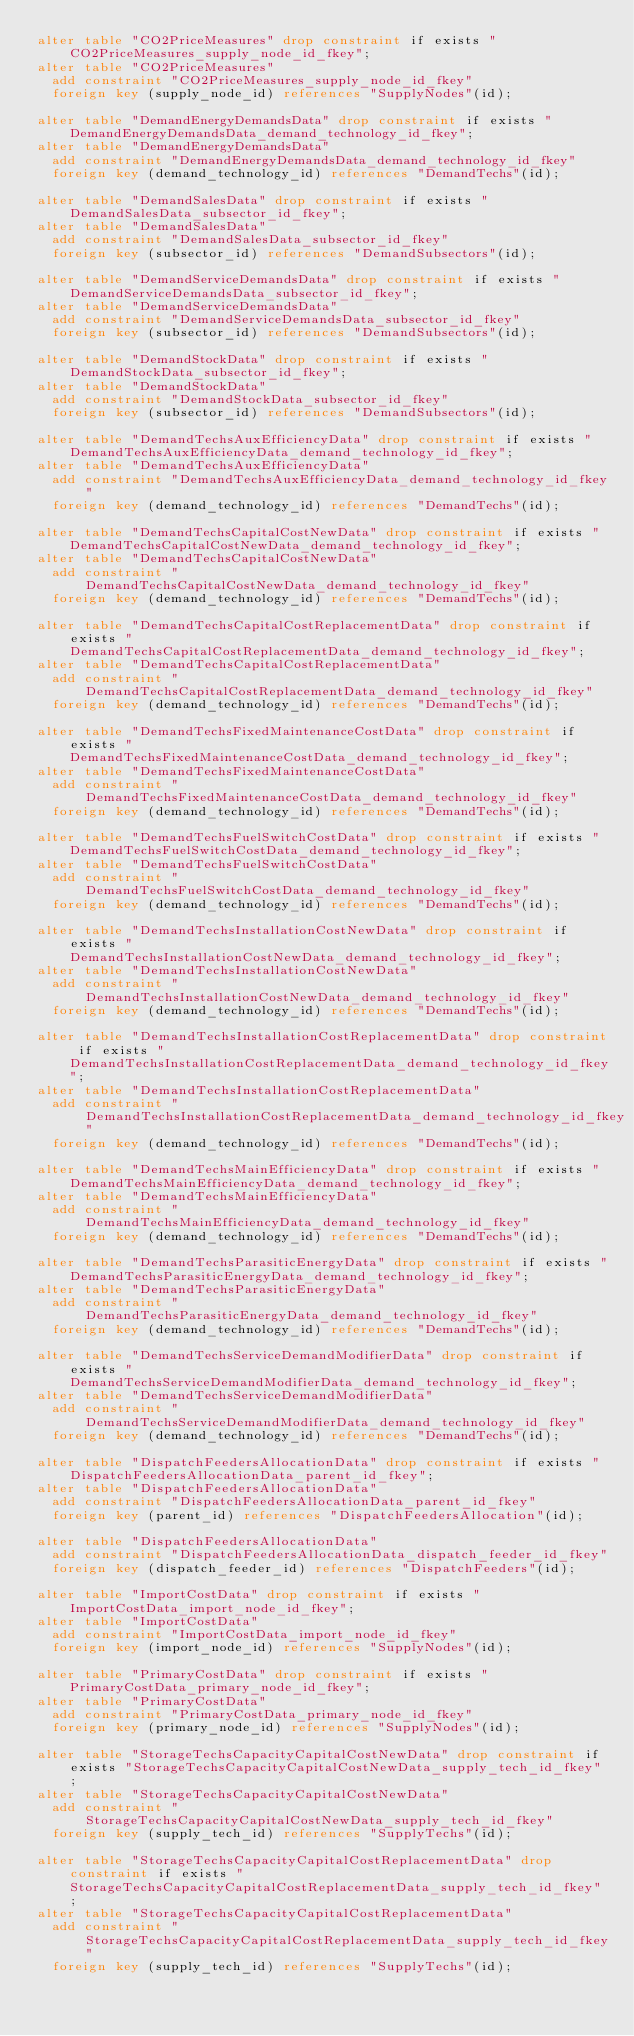Convert code to text. <code><loc_0><loc_0><loc_500><loc_500><_SQL_>alter table "CO2PriceMeasures" drop constraint if exists "CO2PriceMeasures_supply_node_id_fkey";
alter table "CO2PriceMeasures"
  add constraint "CO2PriceMeasures_supply_node_id_fkey"
  foreign key (supply_node_id) references "SupplyNodes"(id);

alter table "DemandEnergyDemandsData" drop constraint if exists "DemandEnergyDemandsData_demand_technology_id_fkey";
alter table "DemandEnergyDemandsData"
  add constraint "DemandEnergyDemandsData_demand_technology_id_fkey"
  foreign key (demand_technology_id) references "DemandTechs"(id);

alter table "DemandSalesData" drop constraint if exists "DemandSalesData_subsector_id_fkey";
alter table "DemandSalesData"
  add constraint "DemandSalesData_subsector_id_fkey"
  foreign key (subsector_id) references "DemandSubsectors"(id);

alter table "DemandServiceDemandsData" drop constraint if exists "DemandServiceDemandsData_subsector_id_fkey";
alter table "DemandServiceDemandsData"
  add constraint "DemandServiceDemandsData_subsector_id_fkey"
  foreign key (subsector_id) references "DemandSubsectors"(id);

alter table "DemandStockData" drop constraint if exists "DemandStockData_subsector_id_fkey";
alter table "DemandStockData"
  add constraint "DemandStockData_subsector_id_fkey"
  foreign key (subsector_id) references "DemandSubsectors"(id);

alter table "DemandTechsAuxEfficiencyData" drop constraint if exists "DemandTechsAuxEfficiencyData_demand_technology_id_fkey";
alter table "DemandTechsAuxEfficiencyData"
  add constraint "DemandTechsAuxEfficiencyData_demand_technology_id_fkey"
  foreign key (demand_technology_id) references "DemandTechs"(id);

alter table "DemandTechsCapitalCostNewData" drop constraint if exists "DemandTechsCapitalCostNewData_demand_technology_id_fkey";
alter table "DemandTechsCapitalCostNewData"
  add constraint "DemandTechsCapitalCostNewData_demand_technology_id_fkey"
  foreign key (demand_technology_id) references "DemandTechs"(id);

alter table "DemandTechsCapitalCostReplacementData" drop constraint if exists "DemandTechsCapitalCostReplacementData_demand_technology_id_fkey";
alter table "DemandTechsCapitalCostReplacementData"
  add constraint "DemandTechsCapitalCostReplacementData_demand_technology_id_fkey"
  foreign key (demand_technology_id) references "DemandTechs"(id);

alter table "DemandTechsFixedMaintenanceCostData" drop constraint if exists "DemandTechsFixedMaintenanceCostData_demand_technology_id_fkey";
alter table "DemandTechsFixedMaintenanceCostData"
  add constraint "DemandTechsFixedMaintenanceCostData_demand_technology_id_fkey"
  foreign key (demand_technology_id) references "DemandTechs"(id);

alter table "DemandTechsFuelSwitchCostData" drop constraint if exists "DemandTechsFuelSwitchCostData_demand_technology_id_fkey";
alter table "DemandTechsFuelSwitchCostData"
  add constraint "DemandTechsFuelSwitchCostData_demand_technology_id_fkey"
  foreign key (demand_technology_id) references "DemandTechs"(id);

alter table "DemandTechsInstallationCostNewData" drop constraint if exists "DemandTechsInstallationCostNewData_demand_technology_id_fkey";
alter table "DemandTechsInstallationCostNewData"
  add constraint "DemandTechsInstallationCostNewData_demand_technology_id_fkey"
  foreign key (demand_technology_id) references "DemandTechs"(id);

alter table "DemandTechsInstallationCostReplacementData" drop constraint if exists "DemandTechsInstallationCostReplacementData_demand_technology_id_fkey";
alter table "DemandTechsInstallationCostReplacementData"
  add constraint "DemandTechsInstallationCostReplacementData_demand_technology_id_fkey"
  foreign key (demand_technology_id) references "DemandTechs"(id);

alter table "DemandTechsMainEfficiencyData" drop constraint if exists "DemandTechsMainEfficiencyData_demand_technology_id_fkey";
alter table "DemandTechsMainEfficiencyData"
  add constraint "DemandTechsMainEfficiencyData_demand_technology_id_fkey"
  foreign key (demand_technology_id) references "DemandTechs"(id);

alter table "DemandTechsParasiticEnergyData" drop constraint if exists "DemandTechsParasiticEnergyData_demand_technology_id_fkey";
alter table "DemandTechsParasiticEnergyData"
  add constraint "DemandTechsParasiticEnergyData_demand_technology_id_fkey"
  foreign key (demand_technology_id) references "DemandTechs"(id);

alter table "DemandTechsServiceDemandModifierData" drop constraint if exists "DemandTechsServiceDemandModifierData_demand_technology_id_fkey";
alter table "DemandTechsServiceDemandModifierData"
  add constraint "DemandTechsServiceDemandModifierData_demand_technology_id_fkey"
  foreign key (demand_technology_id) references "DemandTechs"(id);

alter table "DispatchFeedersAllocationData" drop constraint if exists "DispatchFeedersAllocationData_parent_id_fkey";
alter table "DispatchFeedersAllocationData"
  add constraint "DispatchFeedersAllocationData_parent_id_fkey"
  foreign key (parent_id) references "DispatchFeedersAllocation"(id);

alter table "DispatchFeedersAllocationData"
  add constraint "DispatchFeedersAllocationData_dispatch_feeder_id_fkey"
  foreign key (dispatch_feeder_id) references "DispatchFeeders"(id);

alter table "ImportCostData" drop constraint if exists "ImportCostData_import_node_id_fkey";
alter table "ImportCostData"
  add constraint "ImportCostData_import_node_id_fkey"
  foreign key (import_node_id) references "SupplyNodes"(id);

alter table "PrimaryCostData" drop constraint if exists "PrimaryCostData_primary_node_id_fkey";
alter table "PrimaryCostData"
  add constraint "PrimaryCostData_primary_node_id_fkey"
  foreign key (primary_node_id) references "SupplyNodes"(id);

alter table "StorageTechsCapacityCapitalCostNewData" drop constraint if exists "StorageTechsCapacityCapitalCostNewData_supply_tech_id_fkey";
alter table "StorageTechsCapacityCapitalCostNewData"
  add constraint "StorageTechsCapacityCapitalCostNewData_supply_tech_id_fkey"
  foreign key (supply_tech_id) references "SupplyTechs"(id);

alter table "StorageTechsCapacityCapitalCostReplacementData" drop constraint if exists "StorageTechsCapacityCapitalCostReplacementData_supply_tech_id_fkey";
alter table "StorageTechsCapacityCapitalCostReplacementData"
  add constraint "StorageTechsCapacityCapitalCostReplacementData_supply_tech_id_fkey"
  foreign key (supply_tech_id) references "SupplyTechs"(id);
</code> 